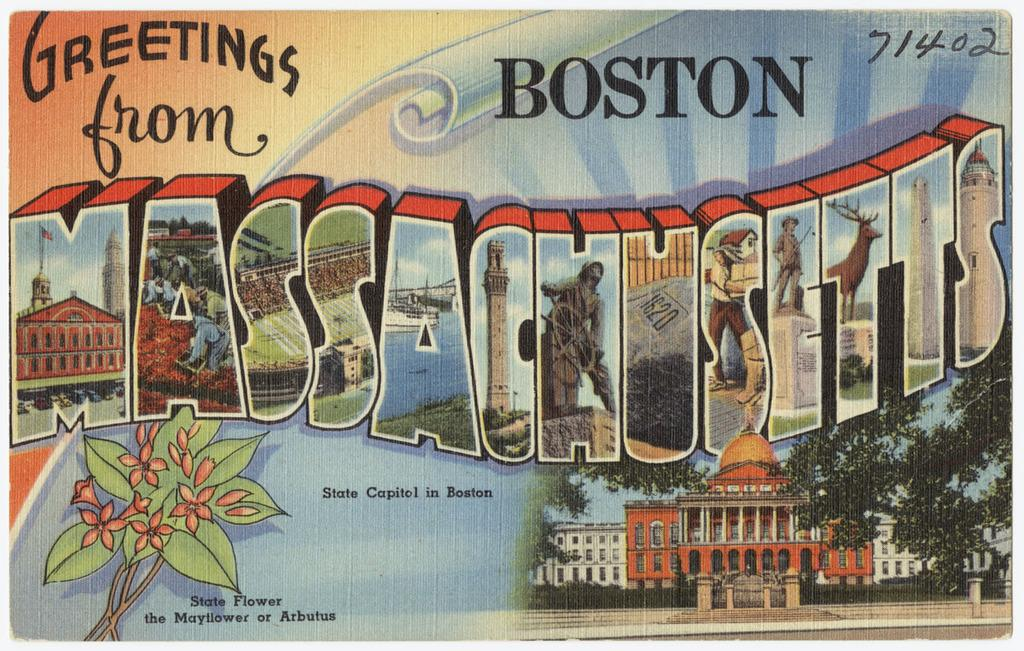<image>
Relay a brief, clear account of the picture shown. A postcard that says Greetings from Boston on the front. 